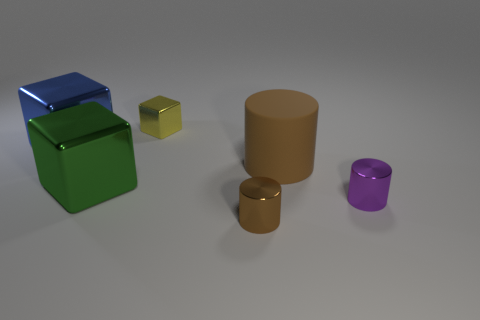Is there any other thing that is the same material as the large cylinder?
Keep it short and to the point. No. Does the tiny shiny cylinder that is left of the brown rubber cylinder have the same color as the large thing on the right side of the brown metal cylinder?
Make the answer very short. Yes. The brown metallic thing that is the same size as the purple cylinder is what shape?
Your answer should be compact. Cylinder. How many objects are brown cylinders behind the large green object or things in front of the yellow metallic block?
Your answer should be very brief. 5. Is the number of yellow matte things less than the number of blue metal things?
Offer a very short reply. Yes. There is a cube that is the same size as the purple thing; what is its material?
Make the answer very short. Metal. There is a brown thing that is in front of the purple shiny cylinder; is its size the same as the shiny block behind the large blue metal cube?
Your response must be concise. Yes. Are there any big cylinders made of the same material as the blue object?
Provide a short and direct response. No. What number of objects are big objects that are left of the tiny block or rubber cylinders?
Your response must be concise. 3. Does the small thing that is behind the small purple metallic cylinder have the same material as the big brown cylinder?
Keep it short and to the point. No. 